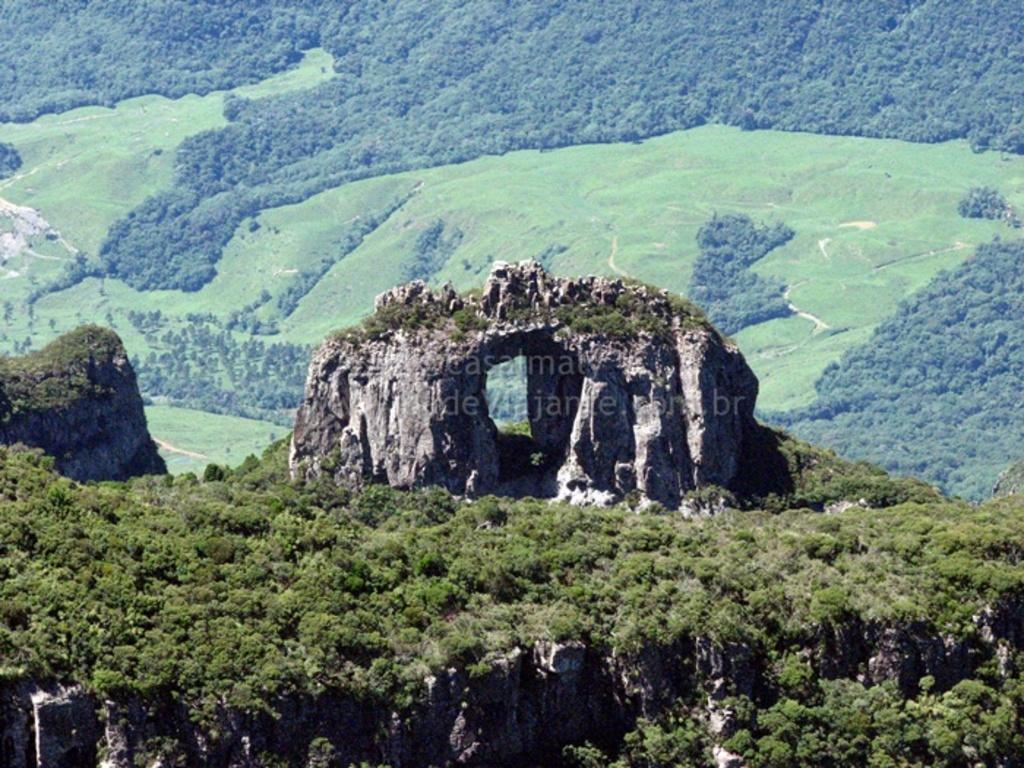In one or two sentences, can you explain what this image depicts? In the image there is a huge rock on a hill and around the rock there is a lot of greenery and in the background there is a lot of grass surface and trees. 